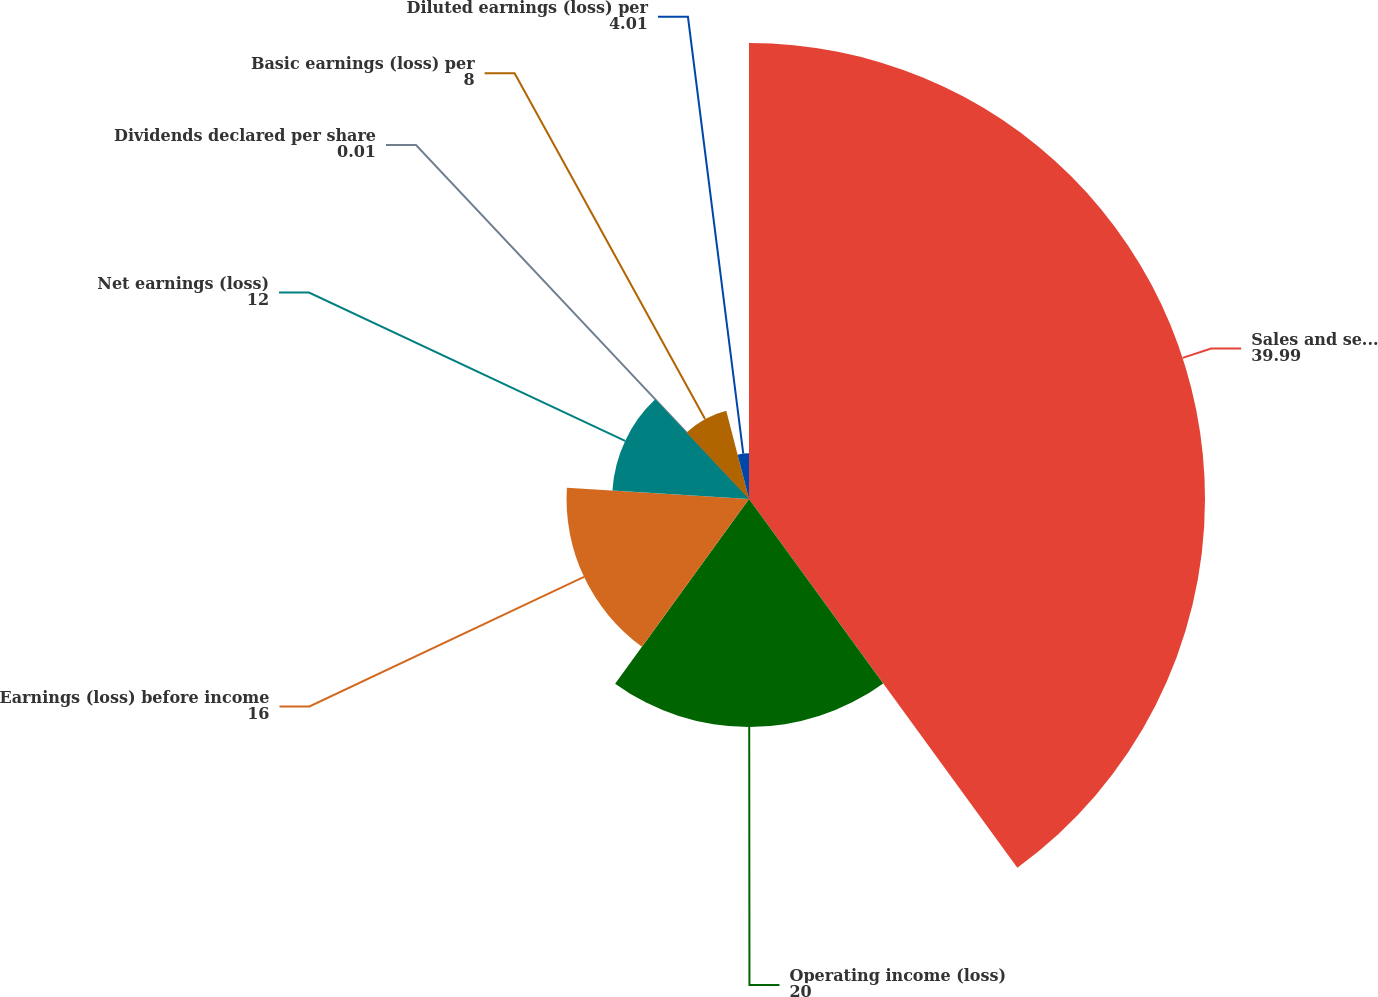<chart> <loc_0><loc_0><loc_500><loc_500><pie_chart><fcel>Sales and service revenues<fcel>Operating income (loss)<fcel>Earnings (loss) before income<fcel>Net earnings (loss)<fcel>Dividends declared per share<fcel>Basic earnings (loss) per<fcel>Diluted earnings (loss) per<nl><fcel>39.99%<fcel>20.0%<fcel>16.0%<fcel>12.0%<fcel>0.01%<fcel>8.0%<fcel>4.01%<nl></chart> 